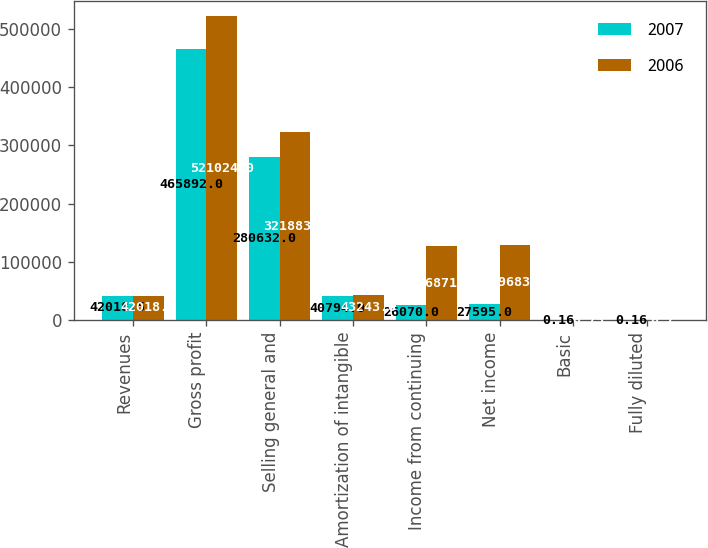Convert chart. <chart><loc_0><loc_0><loc_500><loc_500><stacked_bar_chart><ecel><fcel>Revenues<fcel>Gross profit<fcel>Selling general and<fcel>Amortization of intangible<fcel>Income from continuing<fcel>Net income<fcel>Basic<fcel>Fully diluted<nl><fcel>2007<fcel>42018.5<fcel>465892<fcel>280632<fcel>40794<fcel>26070<fcel>27595<fcel>0.16<fcel>0.16<nl><fcel>2006<fcel>42018.5<fcel>521024<fcel>321883<fcel>43243<fcel>126871<fcel>129683<fcel>0.75<fcel>0.7<nl></chart> 